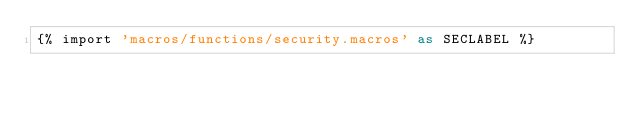Convert code to text. <code><loc_0><loc_0><loc_500><loc_500><_SQL_>{% import 'macros/functions/security.macros' as SECLABEL %}</code> 